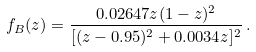Convert formula to latex. <formula><loc_0><loc_0><loc_500><loc_500>f _ { B } ( z ) = \frac { 0 . 0 2 6 4 7 z ( 1 - z ) ^ { 2 } } { [ ( z - 0 . 9 5 ) ^ { 2 } + 0 . 0 0 3 4 z ] ^ { 2 } } \, .</formula> 